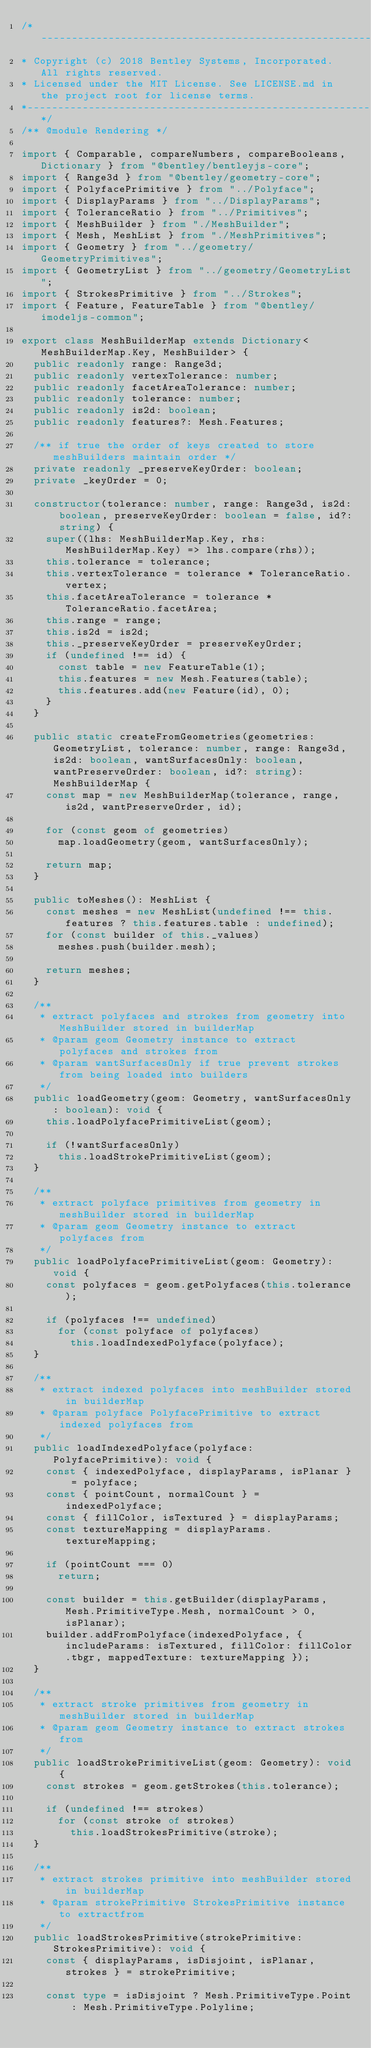<code> <loc_0><loc_0><loc_500><loc_500><_TypeScript_>/*---------------------------------------------------------------------------------------------
* Copyright (c) 2018 Bentley Systems, Incorporated. All rights reserved.
* Licensed under the MIT License. See LICENSE.md in the project root for license terms.
*--------------------------------------------------------------------------------------------*/
/** @module Rendering */

import { Comparable, compareNumbers, compareBooleans, Dictionary } from "@bentley/bentleyjs-core";
import { Range3d } from "@bentley/geometry-core";
import { PolyfacePrimitive } from "../Polyface";
import { DisplayParams } from "../DisplayParams";
import { ToleranceRatio } from "../Primitives";
import { MeshBuilder } from "./MeshBuilder";
import { Mesh, MeshList } from "./MeshPrimitives";
import { Geometry } from "../geometry/GeometryPrimitives";
import { GeometryList } from "../geometry/GeometryList";
import { StrokesPrimitive } from "../Strokes";
import { Feature, FeatureTable } from "@bentley/imodeljs-common";

export class MeshBuilderMap extends Dictionary<MeshBuilderMap.Key, MeshBuilder> {
  public readonly range: Range3d;
  public readonly vertexTolerance: number;
  public readonly facetAreaTolerance: number;
  public readonly tolerance: number;
  public readonly is2d: boolean;
  public readonly features?: Mesh.Features;

  /** if true the order of keys created to store meshBuilders maintain order */
  private readonly _preserveKeyOrder: boolean;
  private _keyOrder = 0;

  constructor(tolerance: number, range: Range3d, is2d: boolean, preserveKeyOrder: boolean = false, id?: string) {
    super((lhs: MeshBuilderMap.Key, rhs: MeshBuilderMap.Key) => lhs.compare(rhs));
    this.tolerance = tolerance;
    this.vertexTolerance = tolerance * ToleranceRatio.vertex;
    this.facetAreaTolerance = tolerance * ToleranceRatio.facetArea;
    this.range = range;
    this.is2d = is2d;
    this._preserveKeyOrder = preserveKeyOrder;
    if (undefined !== id) {
      const table = new FeatureTable(1);
      this.features = new Mesh.Features(table);
      this.features.add(new Feature(id), 0);
    }
  }

  public static createFromGeometries(geometries: GeometryList, tolerance: number, range: Range3d, is2d: boolean, wantSurfacesOnly: boolean, wantPreserveOrder: boolean, id?: string): MeshBuilderMap {
    const map = new MeshBuilderMap(tolerance, range, is2d, wantPreserveOrder, id);

    for (const geom of geometries)
      map.loadGeometry(geom, wantSurfacesOnly);

    return map;
  }

  public toMeshes(): MeshList {
    const meshes = new MeshList(undefined !== this.features ? this.features.table : undefined);
    for (const builder of this._values)
      meshes.push(builder.mesh);

    return meshes;
  }

  /**
   * extract polyfaces and strokes from geometry into MeshBuilder stored in builderMap
   * @param geom Geometry instance to extract polyfaces and strokes from
   * @param wantSurfacesOnly if true prevent strokes from being loaded into builders
   */
  public loadGeometry(geom: Geometry, wantSurfacesOnly: boolean): void {
    this.loadPolyfacePrimitiveList(geom);

    if (!wantSurfacesOnly)
      this.loadStrokePrimitiveList(geom);
  }

  /**
   * extract polyface primitives from geometry in meshBuilder stored in builderMap
   * @param geom Geometry instance to extract polyfaces from
   */
  public loadPolyfacePrimitiveList(geom: Geometry): void {
    const polyfaces = geom.getPolyfaces(this.tolerance);

    if (polyfaces !== undefined)
      for (const polyface of polyfaces)
        this.loadIndexedPolyface(polyface);
  }

  /**
   * extract indexed polyfaces into meshBuilder stored in builderMap
   * @param polyface PolyfacePrimitive to extract indexed polyfaces from
   */
  public loadIndexedPolyface(polyface: PolyfacePrimitive): void {
    const { indexedPolyface, displayParams, isPlanar } = polyface;
    const { pointCount, normalCount } = indexedPolyface;
    const { fillColor, isTextured } = displayParams;
    const textureMapping = displayParams.textureMapping;

    if (pointCount === 0)
      return;

    const builder = this.getBuilder(displayParams, Mesh.PrimitiveType.Mesh, normalCount > 0, isPlanar);
    builder.addFromPolyface(indexedPolyface, { includeParams: isTextured, fillColor: fillColor.tbgr, mappedTexture: textureMapping });
  }

  /**
   * extract stroke primitives from geometry in meshBuilder stored in builderMap
   * @param geom Geometry instance to extract strokes from
   */
  public loadStrokePrimitiveList(geom: Geometry): void {
    const strokes = geom.getStrokes(this.tolerance);

    if (undefined !== strokes)
      for (const stroke of strokes)
        this.loadStrokesPrimitive(stroke);
  }

  /**
   * extract strokes primitive into meshBuilder stored in builderMap
   * @param strokePrimitive StrokesPrimitive instance to extractfrom
   */
  public loadStrokesPrimitive(strokePrimitive: StrokesPrimitive): void {
    const { displayParams, isDisjoint, isPlanar, strokes } = strokePrimitive;

    const type = isDisjoint ? Mesh.PrimitiveType.Point : Mesh.PrimitiveType.Polyline;</code> 